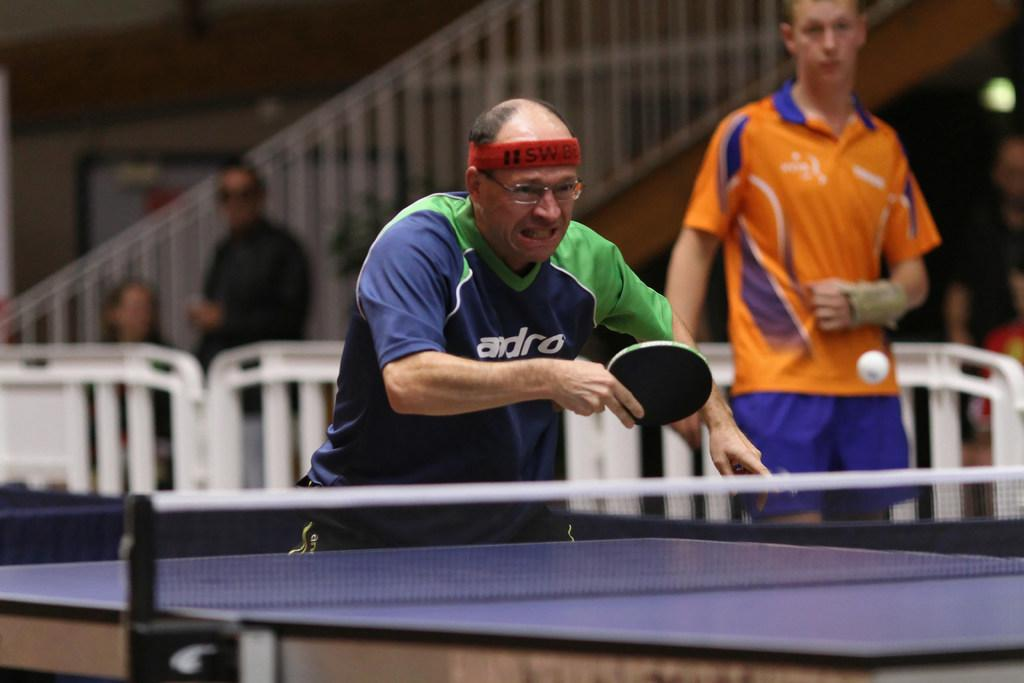What is the main subject of the image? The main subject of the image is a man playing table tennis. Can you describe the man's actions in the image? The man is standing and playing table tennis. Are there any other people visible in the image? Yes, there is another man standing in the background. Is there a third person in the background? It is unclear if there is a third person in the background, as the fact is less clear and could be a transcription error. What type of card is the man using to play table tennis in the image? There is no card present in the image; the man is playing table tennis with a table tennis paddle. 